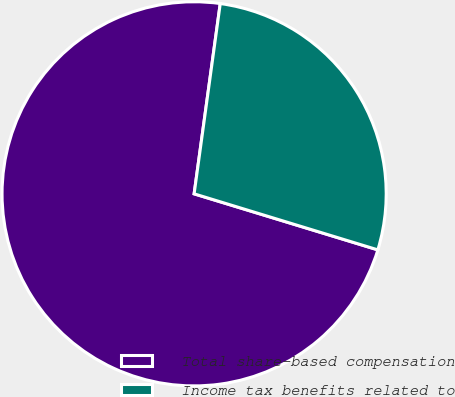<chart> <loc_0><loc_0><loc_500><loc_500><pie_chart><fcel>Total share-based compensation<fcel>Income tax benefits related to<nl><fcel>72.46%<fcel>27.54%<nl></chart> 